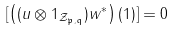Convert formula to latex. <formula><loc_0><loc_0><loc_500><loc_500>[ \left ( ( u \otimes 1 _ { \mathcal { Z } _ { \mathfrak { p } , \mathfrak { q } } } ) w ^ { * } \right ) ( 1 ) ] = 0</formula> 